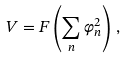Convert formula to latex. <formula><loc_0><loc_0><loc_500><loc_500>V = F \left ( \sum _ { n } \varphi _ { n } ^ { 2 } \right ) \, ,</formula> 